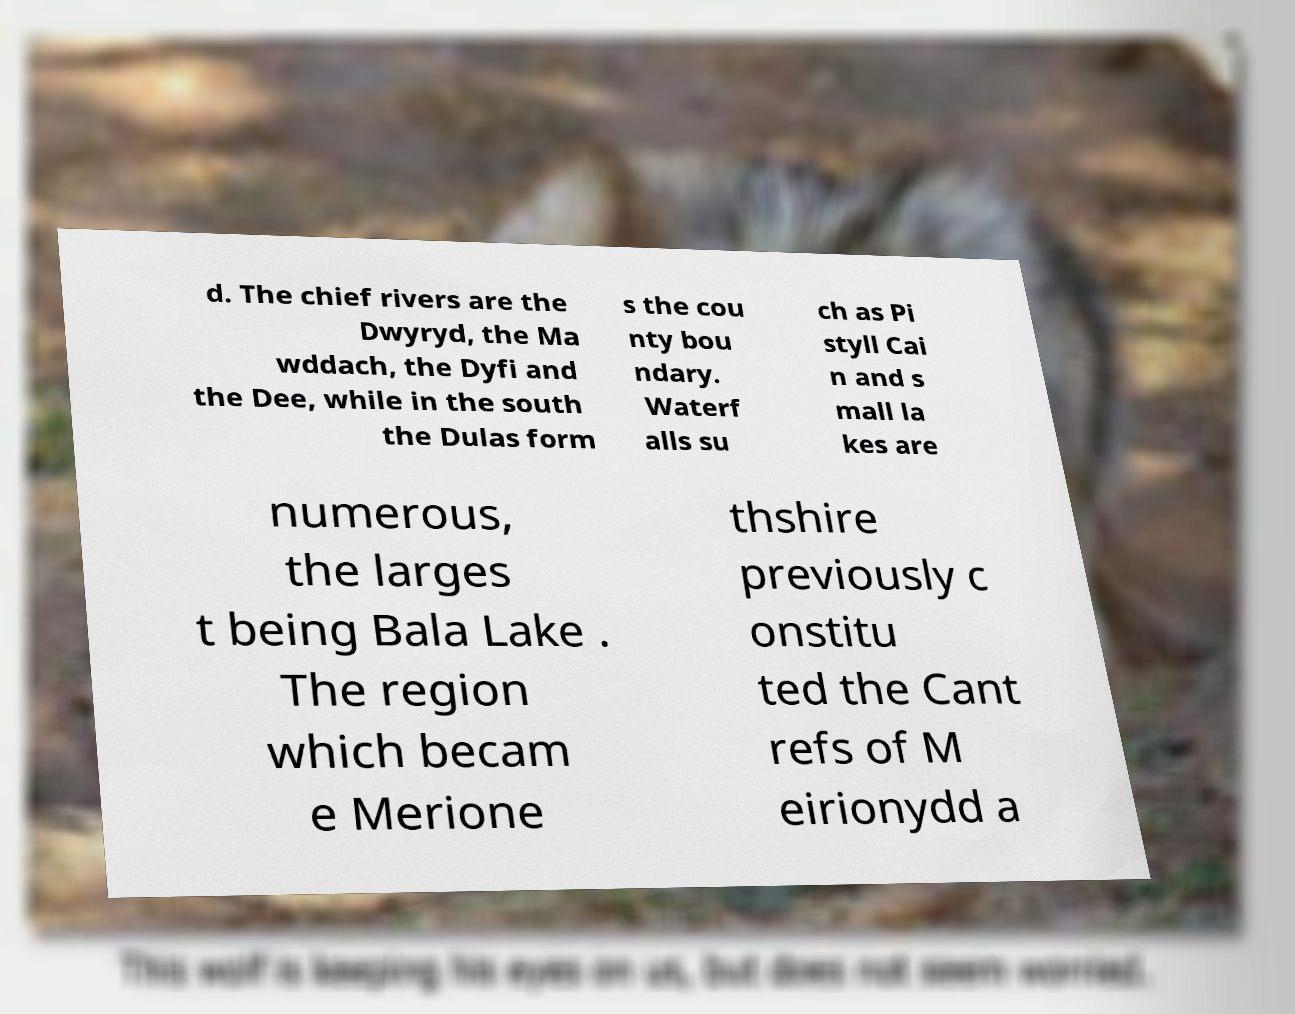Can you accurately transcribe the text from the provided image for me? d. The chief rivers are the Dwyryd, the Ma wddach, the Dyfi and the Dee, while in the south the Dulas form s the cou nty bou ndary. Waterf alls su ch as Pi styll Cai n and s mall la kes are numerous, the larges t being Bala Lake . The region which becam e Merione thshire previously c onstitu ted the Cant refs of M eirionydd a 